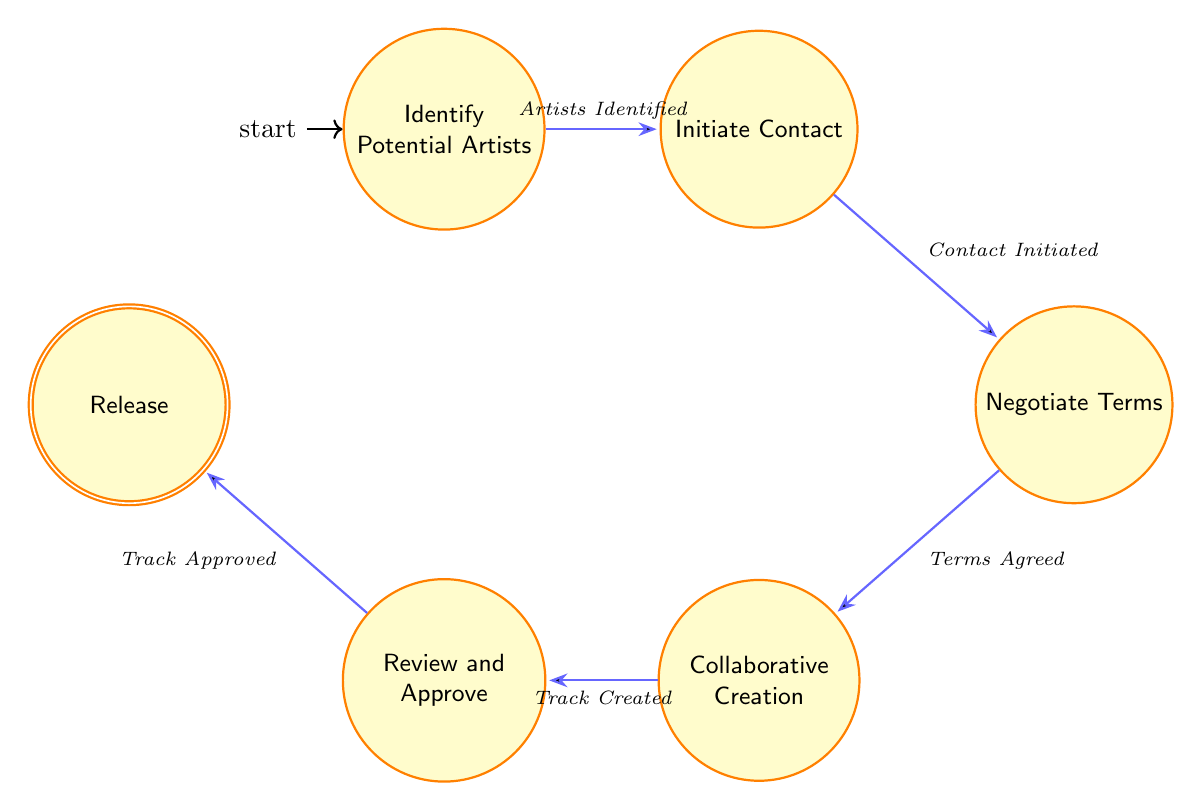What is the first state in the collaboration workflow? The first state is labeled in the diagram as "Identify Potential Artists." By looking at the diagram, we can identify this state as the initial node from where the workflow begins.
Answer: Identify Potential Artists How many states are depicted in the diagram? To determine the number of states, we can count the nodes shown within the structure of the diagram. There are a total of six distinct states presented.
Answer: 6 What action leads from “Collaborative Creation” to “Review and Approve”? The action represented by the transition from the "Collaborative Creation" state to the "Review and Approve" state is labeled as "Track Created." This labeling shows the dependency of the flow from one node to another.
Answer: Track Created In which state do artists negotiate terms? The "Negotiate Terms" state is specifically focused on discussions related to collaboration. By tracing the flow, we see that this is a crucial step, positioned after contacting the artists and before collaborative efforts.
Answer: Negotiate Terms What is the final state in the collaboration workflow? The final state is titled "Release." Examining the diagram, we see this state marked as the last step in the sequence of actions leading to the completion of the collaboration process.
Answer: Release Which state requires listening to drafts and making edits? The state requiring listening to drafts and making edits is "Review and Approve." This state includes actions related to fine-tuning the music before its final version is confirmed.
Answer: Review and Approve Which action connects the “Initiate Contact” state to the “Negotiate Terms” state? The action connecting these two states is labeled "Contact Initiated." This indicates the progression from reaching out to artists to discussing terms of collaboration.
Answer: Contact Initiated What is the relationship between "Negotiate Terms" and "Collaborative Creation"? The relationship is defined by the transition labeled "Terms Agreed," which signifies that once terms are negotiated, the workflow moves into the creative collaboration phase.
Answer: Terms Agreed 